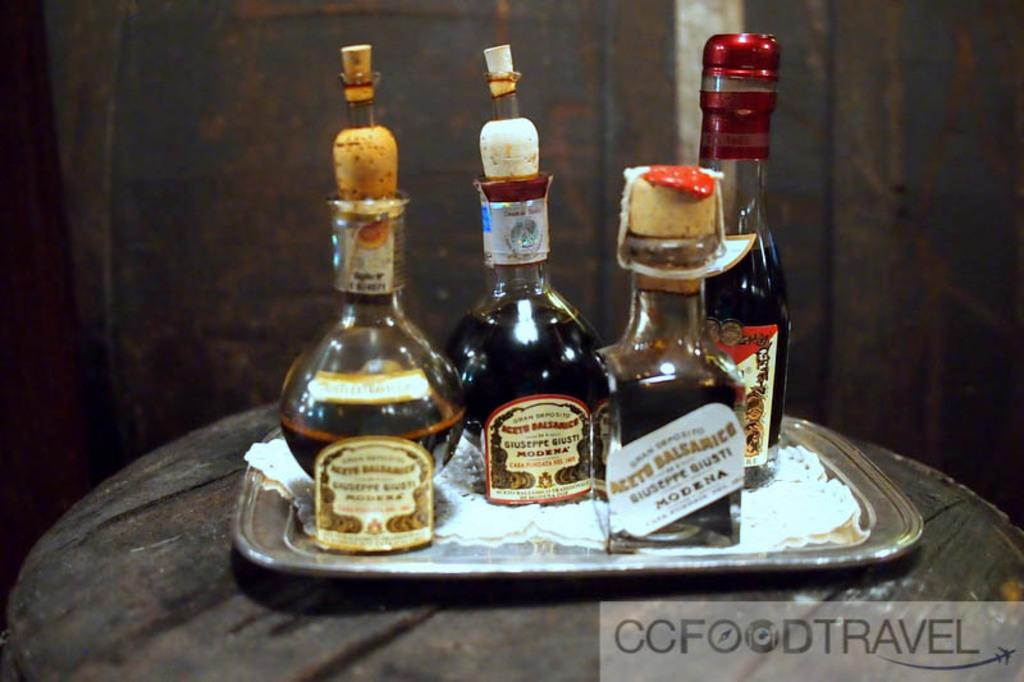What type of furniture is present in the image? There is a table in the image. What is placed on the table? There is a steel tray on the table. What is on the steel tray? There are four bottles on the tray. What feature do the bottles have? The bottles have cock pits for sealing. What type of writing can be seen on the bottles in the image? There is no writing visible on the bottles in the image. How many houses are present in the image? There are no houses present in the image. 